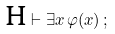Convert formula to latex. <formula><loc_0><loc_0><loc_500><loc_500>\text {H} \vdash \exists x \, \varphi ( x ) \, ;</formula> 